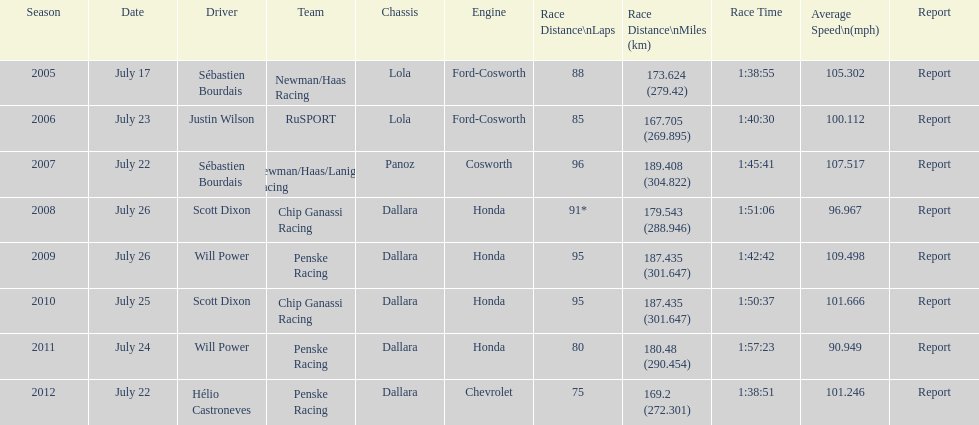How many symbols, apart from france (the primary flag), are demonstrated? 3. 